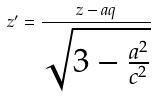<formula> <loc_0><loc_0><loc_500><loc_500>z ^ { \prime } = \frac { z - a q } { \sqrt { 3 - \frac { a ^ { 2 } } { c ^ { 2 } } } }</formula> 